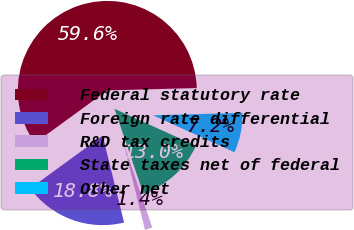Convert chart to OTSL. <chart><loc_0><loc_0><loc_500><loc_500><pie_chart><fcel>Federal statutory rate<fcel>Foreign rate differential<fcel>R&D tax credits<fcel>State taxes net of federal<fcel>Other net<nl><fcel>59.6%<fcel>18.84%<fcel>1.36%<fcel>13.01%<fcel>7.19%<nl></chart> 